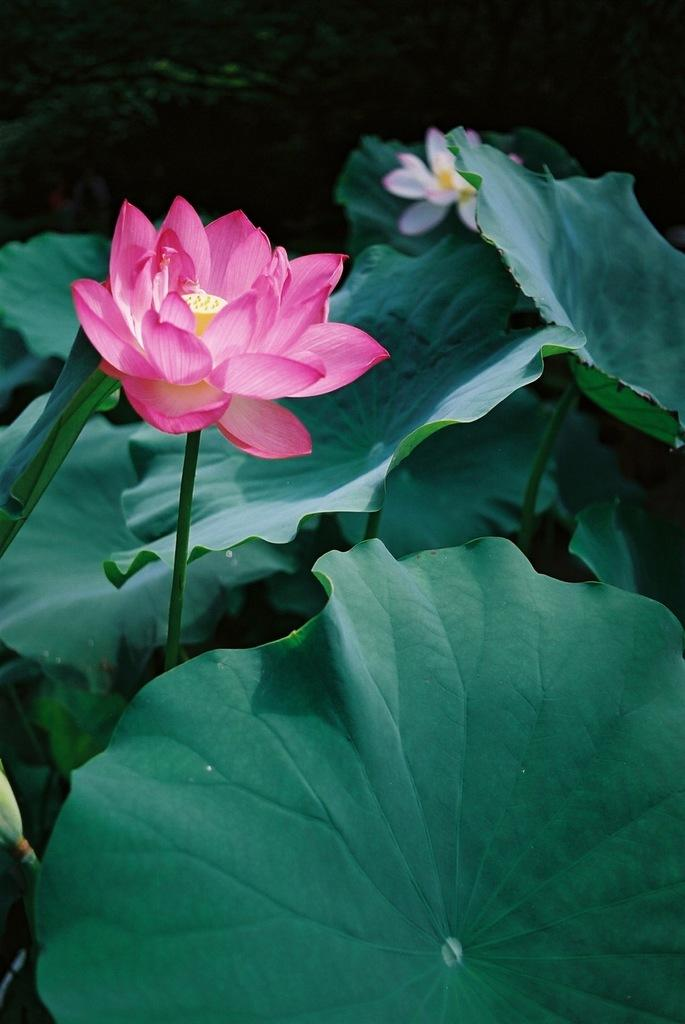What type of plant material is visible in the image? There are leaves in the image. What other type of plant material can be seen in the image? There are flowers in the image. What is the rate of the nerve impulses in the image? There is no reference to nerve impulses or any biological processes in the image, as it features leaves and flowers. What time of day is depicted in the image? The image does not provide any information about the time of day; it only shows leaves and flowers. 